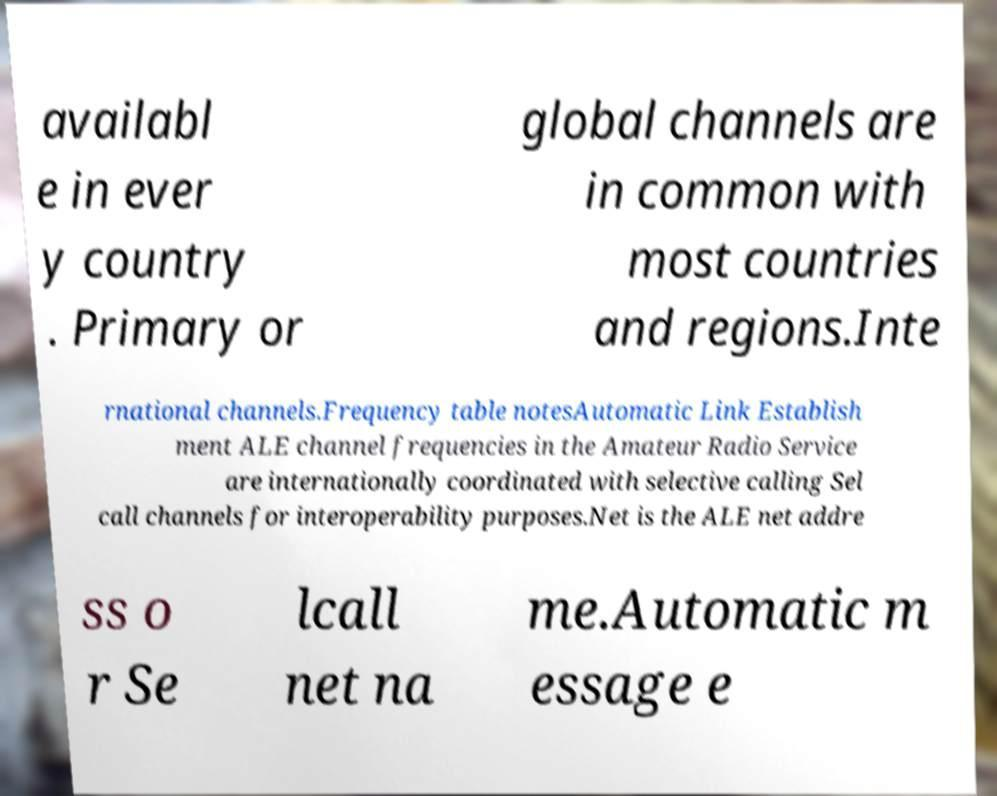Could you assist in decoding the text presented in this image and type it out clearly? availabl e in ever y country . Primary or global channels are in common with most countries and regions.Inte rnational channels.Frequency table notesAutomatic Link Establish ment ALE channel frequencies in the Amateur Radio Service are internationally coordinated with selective calling Sel call channels for interoperability purposes.Net is the ALE net addre ss o r Se lcall net na me.Automatic m essage e 